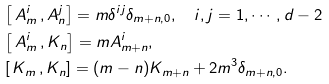<formula> <loc_0><loc_0><loc_500><loc_500>& \left [ \, A ^ { i } _ { m } \, , A ^ { j } _ { n } \right ] = m \delta ^ { i j } \delta _ { m + n , 0 } , \quad i , j = 1 , \cdots , d - 2 \\ & \left [ \, A ^ { i } _ { m } \, , K _ { n } \right ] = m A _ { m + n } ^ { i } , \\ & \left [ \, K _ { m } \, , K _ { n } \right ] = ( m - n ) K _ { m + n } + 2 m ^ { 3 } \delta _ { m + n , 0 } .</formula> 